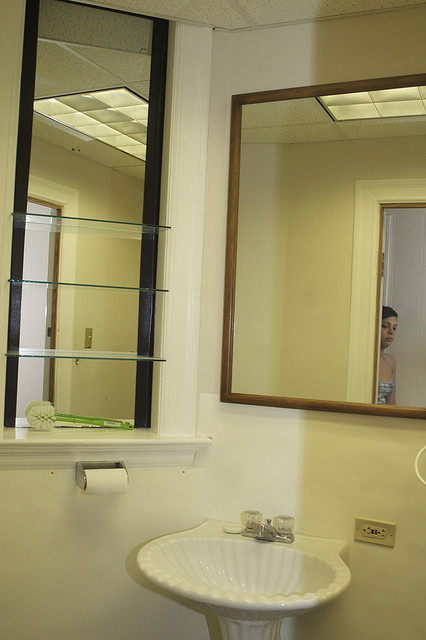<image>Is it a bath or a shower? It is ambiguous whether it is a bath or a shower. Is it a bath or a shower? It is unclear from the given information whether it is a bath or a shower. It could be neither or both. 